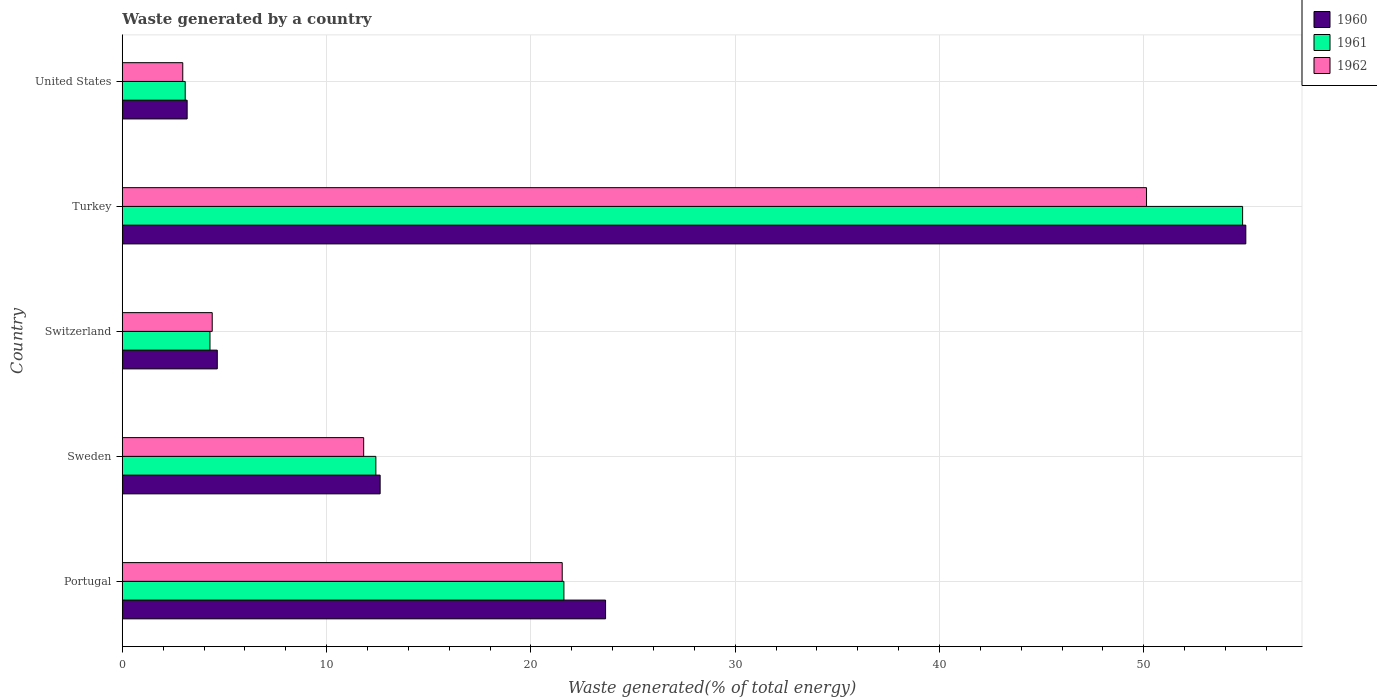Are the number of bars per tick equal to the number of legend labels?
Offer a very short reply. Yes. Are the number of bars on each tick of the Y-axis equal?
Make the answer very short. Yes. What is the label of the 4th group of bars from the top?
Your answer should be very brief. Sweden. What is the total waste generated in 1962 in Portugal?
Provide a short and direct response. 21.53. Across all countries, what is the maximum total waste generated in 1960?
Make the answer very short. 54.99. Across all countries, what is the minimum total waste generated in 1962?
Offer a very short reply. 2.96. In which country was the total waste generated in 1961 maximum?
Provide a succinct answer. Turkey. What is the total total waste generated in 1961 in the graph?
Your response must be concise. 96.24. What is the difference between the total waste generated in 1961 in Sweden and that in Switzerland?
Ensure brevity in your answer.  8.12. What is the difference between the total waste generated in 1960 in Sweden and the total waste generated in 1961 in Portugal?
Make the answer very short. -9. What is the average total waste generated in 1961 per country?
Give a very brief answer. 19.25. What is the difference between the total waste generated in 1962 and total waste generated in 1960 in United States?
Your answer should be compact. -0.21. In how many countries, is the total waste generated in 1961 greater than 14 %?
Make the answer very short. 2. What is the ratio of the total waste generated in 1962 in Turkey to that in United States?
Provide a succinct answer. 16.94. Is the total waste generated in 1960 in Portugal less than that in Switzerland?
Make the answer very short. No. What is the difference between the highest and the second highest total waste generated in 1961?
Keep it short and to the point. 33.22. What is the difference between the highest and the lowest total waste generated in 1962?
Provide a short and direct response. 47.17. What does the 2nd bar from the top in Switzerland represents?
Ensure brevity in your answer.  1961. Is it the case that in every country, the sum of the total waste generated in 1960 and total waste generated in 1962 is greater than the total waste generated in 1961?
Your answer should be compact. Yes. How many bars are there?
Keep it short and to the point. 15. Are all the bars in the graph horizontal?
Offer a terse response. Yes. How many countries are there in the graph?
Give a very brief answer. 5. Does the graph contain grids?
Your answer should be compact. Yes. Where does the legend appear in the graph?
Give a very brief answer. Top right. How many legend labels are there?
Provide a succinct answer. 3. How are the legend labels stacked?
Give a very brief answer. Vertical. What is the title of the graph?
Provide a succinct answer. Waste generated by a country. Does "1984" appear as one of the legend labels in the graph?
Provide a short and direct response. No. What is the label or title of the X-axis?
Ensure brevity in your answer.  Waste generated(% of total energy). What is the Waste generated(% of total energy) in 1960 in Portugal?
Provide a succinct answer. 23.66. What is the Waste generated(% of total energy) in 1961 in Portugal?
Make the answer very short. 21.62. What is the Waste generated(% of total energy) of 1962 in Portugal?
Your answer should be very brief. 21.53. What is the Waste generated(% of total energy) in 1960 in Sweden?
Your answer should be very brief. 12.62. What is the Waste generated(% of total energy) of 1961 in Sweden?
Your response must be concise. 12.41. What is the Waste generated(% of total energy) in 1962 in Sweden?
Your answer should be compact. 11.82. What is the Waste generated(% of total energy) of 1960 in Switzerland?
Offer a terse response. 4.65. What is the Waste generated(% of total energy) in 1961 in Switzerland?
Keep it short and to the point. 4.29. What is the Waste generated(% of total energy) in 1962 in Switzerland?
Offer a very short reply. 4.4. What is the Waste generated(% of total energy) in 1960 in Turkey?
Keep it short and to the point. 54.99. What is the Waste generated(% of total energy) in 1961 in Turkey?
Your response must be concise. 54.84. What is the Waste generated(% of total energy) in 1962 in Turkey?
Your answer should be compact. 50.13. What is the Waste generated(% of total energy) in 1960 in United States?
Your response must be concise. 3.17. What is the Waste generated(% of total energy) of 1961 in United States?
Offer a very short reply. 3.08. What is the Waste generated(% of total energy) of 1962 in United States?
Offer a very short reply. 2.96. Across all countries, what is the maximum Waste generated(% of total energy) in 1960?
Your answer should be compact. 54.99. Across all countries, what is the maximum Waste generated(% of total energy) of 1961?
Offer a terse response. 54.84. Across all countries, what is the maximum Waste generated(% of total energy) of 1962?
Make the answer very short. 50.13. Across all countries, what is the minimum Waste generated(% of total energy) in 1960?
Your answer should be very brief. 3.17. Across all countries, what is the minimum Waste generated(% of total energy) in 1961?
Provide a short and direct response. 3.08. Across all countries, what is the minimum Waste generated(% of total energy) in 1962?
Offer a very short reply. 2.96. What is the total Waste generated(% of total energy) in 1960 in the graph?
Offer a terse response. 99.1. What is the total Waste generated(% of total energy) of 1961 in the graph?
Provide a succinct answer. 96.24. What is the total Waste generated(% of total energy) in 1962 in the graph?
Offer a very short reply. 90.85. What is the difference between the Waste generated(% of total energy) in 1960 in Portugal and that in Sweden?
Provide a short and direct response. 11.03. What is the difference between the Waste generated(% of total energy) of 1961 in Portugal and that in Sweden?
Your answer should be compact. 9.2. What is the difference between the Waste generated(% of total energy) in 1962 in Portugal and that in Sweden?
Your answer should be very brief. 9.72. What is the difference between the Waste generated(% of total energy) in 1960 in Portugal and that in Switzerland?
Ensure brevity in your answer.  19.01. What is the difference between the Waste generated(% of total energy) in 1961 in Portugal and that in Switzerland?
Provide a succinct answer. 17.32. What is the difference between the Waste generated(% of total energy) of 1962 in Portugal and that in Switzerland?
Offer a very short reply. 17.13. What is the difference between the Waste generated(% of total energy) in 1960 in Portugal and that in Turkey?
Your answer should be compact. -31.34. What is the difference between the Waste generated(% of total energy) of 1961 in Portugal and that in Turkey?
Make the answer very short. -33.22. What is the difference between the Waste generated(% of total energy) in 1962 in Portugal and that in Turkey?
Your answer should be very brief. -28.6. What is the difference between the Waste generated(% of total energy) in 1960 in Portugal and that in United States?
Make the answer very short. 20.48. What is the difference between the Waste generated(% of total energy) in 1961 in Portugal and that in United States?
Provide a short and direct response. 18.54. What is the difference between the Waste generated(% of total energy) of 1962 in Portugal and that in United States?
Offer a terse response. 18.57. What is the difference between the Waste generated(% of total energy) of 1960 in Sweden and that in Switzerland?
Your response must be concise. 7.97. What is the difference between the Waste generated(% of total energy) of 1961 in Sweden and that in Switzerland?
Ensure brevity in your answer.  8.12. What is the difference between the Waste generated(% of total energy) of 1962 in Sweden and that in Switzerland?
Keep it short and to the point. 7.41. What is the difference between the Waste generated(% of total energy) in 1960 in Sweden and that in Turkey?
Provide a succinct answer. -42.37. What is the difference between the Waste generated(% of total energy) of 1961 in Sweden and that in Turkey?
Give a very brief answer. -42.43. What is the difference between the Waste generated(% of total energy) in 1962 in Sweden and that in Turkey?
Ensure brevity in your answer.  -38.32. What is the difference between the Waste generated(% of total energy) of 1960 in Sweden and that in United States?
Make the answer very short. 9.45. What is the difference between the Waste generated(% of total energy) of 1961 in Sweden and that in United States?
Keep it short and to the point. 9.33. What is the difference between the Waste generated(% of total energy) in 1962 in Sweden and that in United States?
Keep it short and to the point. 8.86. What is the difference between the Waste generated(% of total energy) in 1960 in Switzerland and that in Turkey?
Your response must be concise. -50.34. What is the difference between the Waste generated(% of total energy) in 1961 in Switzerland and that in Turkey?
Offer a terse response. -50.55. What is the difference between the Waste generated(% of total energy) of 1962 in Switzerland and that in Turkey?
Provide a succinct answer. -45.73. What is the difference between the Waste generated(% of total energy) of 1960 in Switzerland and that in United States?
Make the answer very short. 1.48. What is the difference between the Waste generated(% of total energy) of 1961 in Switzerland and that in United States?
Ensure brevity in your answer.  1.21. What is the difference between the Waste generated(% of total energy) of 1962 in Switzerland and that in United States?
Make the answer very short. 1.44. What is the difference between the Waste generated(% of total energy) in 1960 in Turkey and that in United States?
Your answer should be very brief. 51.82. What is the difference between the Waste generated(% of total energy) of 1961 in Turkey and that in United States?
Your answer should be very brief. 51.76. What is the difference between the Waste generated(% of total energy) in 1962 in Turkey and that in United States?
Provide a short and direct response. 47.17. What is the difference between the Waste generated(% of total energy) of 1960 in Portugal and the Waste generated(% of total energy) of 1961 in Sweden?
Your response must be concise. 11.24. What is the difference between the Waste generated(% of total energy) of 1960 in Portugal and the Waste generated(% of total energy) of 1962 in Sweden?
Ensure brevity in your answer.  11.84. What is the difference between the Waste generated(% of total energy) in 1961 in Portugal and the Waste generated(% of total energy) in 1962 in Sweden?
Your response must be concise. 9.8. What is the difference between the Waste generated(% of total energy) in 1960 in Portugal and the Waste generated(% of total energy) in 1961 in Switzerland?
Your answer should be compact. 19.36. What is the difference between the Waste generated(% of total energy) of 1960 in Portugal and the Waste generated(% of total energy) of 1962 in Switzerland?
Offer a terse response. 19.25. What is the difference between the Waste generated(% of total energy) in 1961 in Portugal and the Waste generated(% of total energy) in 1962 in Switzerland?
Offer a terse response. 17.21. What is the difference between the Waste generated(% of total energy) of 1960 in Portugal and the Waste generated(% of total energy) of 1961 in Turkey?
Your answer should be very brief. -31.18. What is the difference between the Waste generated(% of total energy) of 1960 in Portugal and the Waste generated(% of total energy) of 1962 in Turkey?
Give a very brief answer. -26.48. What is the difference between the Waste generated(% of total energy) of 1961 in Portugal and the Waste generated(% of total energy) of 1962 in Turkey?
Offer a very short reply. -28.52. What is the difference between the Waste generated(% of total energy) in 1960 in Portugal and the Waste generated(% of total energy) in 1961 in United States?
Your answer should be very brief. 20.58. What is the difference between the Waste generated(% of total energy) in 1960 in Portugal and the Waste generated(% of total energy) in 1962 in United States?
Your answer should be very brief. 20.7. What is the difference between the Waste generated(% of total energy) in 1961 in Portugal and the Waste generated(% of total energy) in 1962 in United States?
Offer a terse response. 18.66. What is the difference between the Waste generated(% of total energy) of 1960 in Sweden and the Waste generated(% of total energy) of 1961 in Switzerland?
Give a very brief answer. 8.33. What is the difference between the Waste generated(% of total energy) in 1960 in Sweden and the Waste generated(% of total energy) in 1962 in Switzerland?
Provide a short and direct response. 8.22. What is the difference between the Waste generated(% of total energy) in 1961 in Sweden and the Waste generated(% of total energy) in 1962 in Switzerland?
Offer a terse response. 8.01. What is the difference between the Waste generated(% of total energy) in 1960 in Sweden and the Waste generated(% of total energy) in 1961 in Turkey?
Your response must be concise. -42.22. What is the difference between the Waste generated(% of total energy) in 1960 in Sweden and the Waste generated(% of total energy) in 1962 in Turkey?
Offer a terse response. -37.51. What is the difference between the Waste generated(% of total energy) of 1961 in Sweden and the Waste generated(% of total energy) of 1962 in Turkey?
Your answer should be very brief. -37.72. What is the difference between the Waste generated(% of total energy) in 1960 in Sweden and the Waste generated(% of total energy) in 1961 in United States?
Your answer should be compact. 9.54. What is the difference between the Waste generated(% of total energy) of 1960 in Sweden and the Waste generated(% of total energy) of 1962 in United States?
Your response must be concise. 9.66. What is the difference between the Waste generated(% of total energy) of 1961 in Sweden and the Waste generated(% of total energy) of 1962 in United States?
Provide a short and direct response. 9.45. What is the difference between the Waste generated(% of total energy) of 1960 in Switzerland and the Waste generated(% of total energy) of 1961 in Turkey?
Your response must be concise. -50.19. What is the difference between the Waste generated(% of total energy) in 1960 in Switzerland and the Waste generated(% of total energy) in 1962 in Turkey?
Your response must be concise. -45.48. What is the difference between the Waste generated(% of total energy) in 1961 in Switzerland and the Waste generated(% of total energy) in 1962 in Turkey?
Provide a succinct answer. -45.84. What is the difference between the Waste generated(% of total energy) in 1960 in Switzerland and the Waste generated(% of total energy) in 1961 in United States?
Offer a very short reply. 1.57. What is the difference between the Waste generated(% of total energy) in 1960 in Switzerland and the Waste generated(% of total energy) in 1962 in United States?
Provide a succinct answer. 1.69. What is the difference between the Waste generated(% of total energy) in 1961 in Switzerland and the Waste generated(% of total energy) in 1962 in United States?
Keep it short and to the point. 1.33. What is the difference between the Waste generated(% of total energy) of 1960 in Turkey and the Waste generated(% of total energy) of 1961 in United States?
Your response must be concise. 51.92. What is the difference between the Waste generated(% of total energy) in 1960 in Turkey and the Waste generated(% of total energy) in 1962 in United States?
Your answer should be compact. 52.03. What is the difference between the Waste generated(% of total energy) of 1961 in Turkey and the Waste generated(% of total energy) of 1962 in United States?
Offer a terse response. 51.88. What is the average Waste generated(% of total energy) of 1960 per country?
Keep it short and to the point. 19.82. What is the average Waste generated(% of total energy) in 1961 per country?
Offer a very short reply. 19.25. What is the average Waste generated(% of total energy) of 1962 per country?
Keep it short and to the point. 18.17. What is the difference between the Waste generated(% of total energy) in 1960 and Waste generated(% of total energy) in 1961 in Portugal?
Ensure brevity in your answer.  2.04. What is the difference between the Waste generated(% of total energy) of 1960 and Waste generated(% of total energy) of 1962 in Portugal?
Ensure brevity in your answer.  2.12. What is the difference between the Waste generated(% of total energy) in 1961 and Waste generated(% of total energy) in 1962 in Portugal?
Offer a terse response. 0.08. What is the difference between the Waste generated(% of total energy) of 1960 and Waste generated(% of total energy) of 1961 in Sweden?
Offer a very short reply. 0.21. What is the difference between the Waste generated(% of total energy) of 1960 and Waste generated(% of total energy) of 1962 in Sweden?
Offer a very short reply. 0.81. What is the difference between the Waste generated(% of total energy) in 1961 and Waste generated(% of total energy) in 1962 in Sweden?
Your response must be concise. 0.6. What is the difference between the Waste generated(% of total energy) of 1960 and Waste generated(% of total energy) of 1961 in Switzerland?
Provide a short and direct response. 0.36. What is the difference between the Waste generated(% of total energy) in 1960 and Waste generated(% of total energy) in 1962 in Switzerland?
Offer a very short reply. 0.25. What is the difference between the Waste generated(% of total energy) of 1961 and Waste generated(% of total energy) of 1962 in Switzerland?
Provide a succinct answer. -0.11. What is the difference between the Waste generated(% of total energy) in 1960 and Waste generated(% of total energy) in 1961 in Turkey?
Your response must be concise. 0.16. What is the difference between the Waste generated(% of total energy) of 1960 and Waste generated(% of total energy) of 1962 in Turkey?
Your answer should be compact. 4.86. What is the difference between the Waste generated(% of total energy) in 1961 and Waste generated(% of total energy) in 1962 in Turkey?
Ensure brevity in your answer.  4.7. What is the difference between the Waste generated(% of total energy) in 1960 and Waste generated(% of total energy) in 1961 in United States?
Provide a short and direct response. 0.1. What is the difference between the Waste generated(% of total energy) of 1960 and Waste generated(% of total energy) of 1962 in United States?
Keep it short and to the point. 0.21. What is the difference between the Waste generated(% of total energy) in 1961 and Waste generated(% of total energy) in 1962 in United States?
Keep it short and to the point. 0.12. What is the ratio of the Waste generated(% of total energy) in 1960 in Portugal to that in Sweden?
Give a very brief answer. 1.87. What is the ratio of the Waste generated(% of total energy) in 1961 in Portugal to that in Sweden?
Your response must be concise. 1.74. What is the ratio of the Waste generated(% of total energy) of 1962 in Portugal to that in Sweden?
Your answer should be very brief. 1.82. What is the ratio of the Waste generated(% of total energy) in 1960 in Portugal to that in Switzerland?
Your response must be concise. 5.09. What is the ratio of the Waste generated(% of total energy) of 1961 in Portugal to that in Switzerland?
Your answer should be very brief. 5.04. What is the ratio of the Waste generated(% of total energy) of 1962 in Portugal to that in Switzerland?
Provide a succinct answer. 4.89. What is the ratio of the Waste generated(% of total energy) in 1960 in Portugal to that in Turkey?
Your answer should be very brief. 0.43. What is the ratio of the Waste generated(% of total energy) of 1961 in Portugal to that in Turkey?
Your answer should be very brief. 0.39. What is the ratio of the Waste generated(% of total energy) in 1962 in Portugal to that in Turkey?
Provide a short and direct response. 0.43. What is the ratio of the Waste generated(% of total energy) of 1960 in Portugal to that in United States?
Provide a succinct answer. 7.45. What is the ratio of the Waste generated(% of total energy) in 1961 in Portugal to that in United States?
Provide a short and direct response. 7.02. What is the ratio of the Waste generated(% of total energy) in 1962 in Portugal to that in United States?
Offer a very short reply. 7.27. What is the ratio of the Waste generated(% of total energy) in 1960 in Sweden to that in Switzerland?
Offer a very short reply. 2.71. What is the ratio of the Waste generated(% of total energy) in 1961 in Sweden to that in Switzerland?
Make the answer very short. 2.89. What is the ratio of the Waste generated(% of total energy) in 1962 in Sweden to that in Switzerland?
Offer a terse response. 2.68. What is the ratio of the Waste generated(% of total energy) of 1960 in Sweden to that in Turkey?
Give a very brief answer. 0.23. What is the ratio of the Waste generated(% of total energy) of 1961 in Sweden to that in Turkey?
Offer a very short reply. 0.23. What is the ratio of the Waste generated(% of total energy) of 1962 in Sweden to that in Turkey?
Provide a short and direct response. 0.24. What is the ratio of the Waste generated(% of total energy) of 1960 in Sweden to that in United States?
Your response must be concise. 3.98. What is the ratio of the Waste generated(% of total energy) of 1961 in Sweden to that in United States?
Keep it short and to the point. 4.03. What is the ratio of the Waste generated(% of total energy) of 1962 in Sweden to that in United States?
Your answer should be very brief. 3.99. What is the ratio of the Waste generated(% of total energy) of 1960 in Switzerland to that in Turkey?
Your answer should be very brief. 0.08. What is the ratio of the Waste generated(% of total energy) in 1961 in Switzerland to that in Turkey?
Provide a succinct answer. 0.08. What is the ratio of the Waste generated(% of total energy) in 1962 in Switzerland to that in Turkey?
Provide a short and direct response. 0.09. What is the ratio of the Waste generated(% of total energy) in 1960 in Switzerland to that in United States?
Offer a terse response. 1.46. What is the ratio of the Waste generated(% of total energy) of 1961 in Switzerland to that in United States?
Provide a succinct answer. 1.39. What is the ratio of the Waste generated(% of total energy) in 1962 in Switzerland to that in United States?
Keep it short and to the point. 1.49. What is the ratio of the Waste generated(% of total energy) of 1960 in Turkey to that in United States?
Provide a short and direct response. 17.32. What is the ratio of the Waste generated(% of total energy) in 1961 in Turkey to that in United States?
Give a very brief answer. 17.81. What is the ratio of the Waste generated(% of total energy) in 1962 in Turkey to that in United States?
Offer a terse response. 16.94. What is the difference between the highest and the second highest Waste generated(% of total energy) in 1960?
Offer a terse response. 31.34. What is the difference between the highest and the second highest Waste generated(% of total energy) in 1961?
Offer a terse response. 33.22. What is the difference between the highest and the second highest Waste generated(% of total energy) in 1962?
Make the answer very short. 28.6. What is the difference between the highest and the lowest Waste generated(% of total energy) of 1960?
Your answer should be compact. 51.82. What is the difference between the highest and the lowest Waste generated(% of total energy) in 1961?
Offer a very short reply. 51.76. What is the difference between the highest and the lowest Waste generated(% of total energy) in 1962?
Offer a terse response. 47.17. 